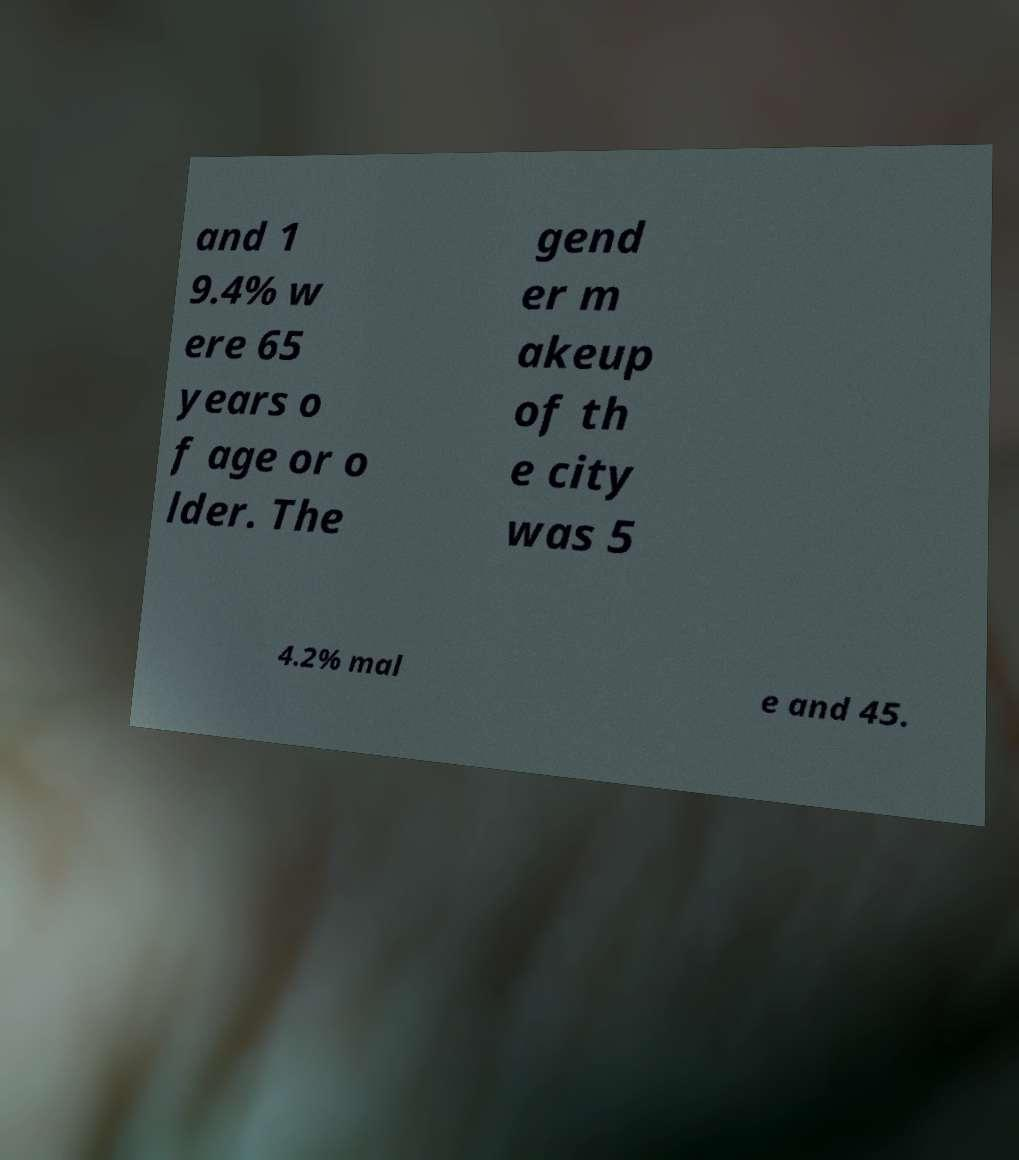Could you extract and type out the text from this image? and 1 9.4% w ere 65 years o f age or o lder. The gend er m akeup of th e city was 5 4.2% mal e and 45. 